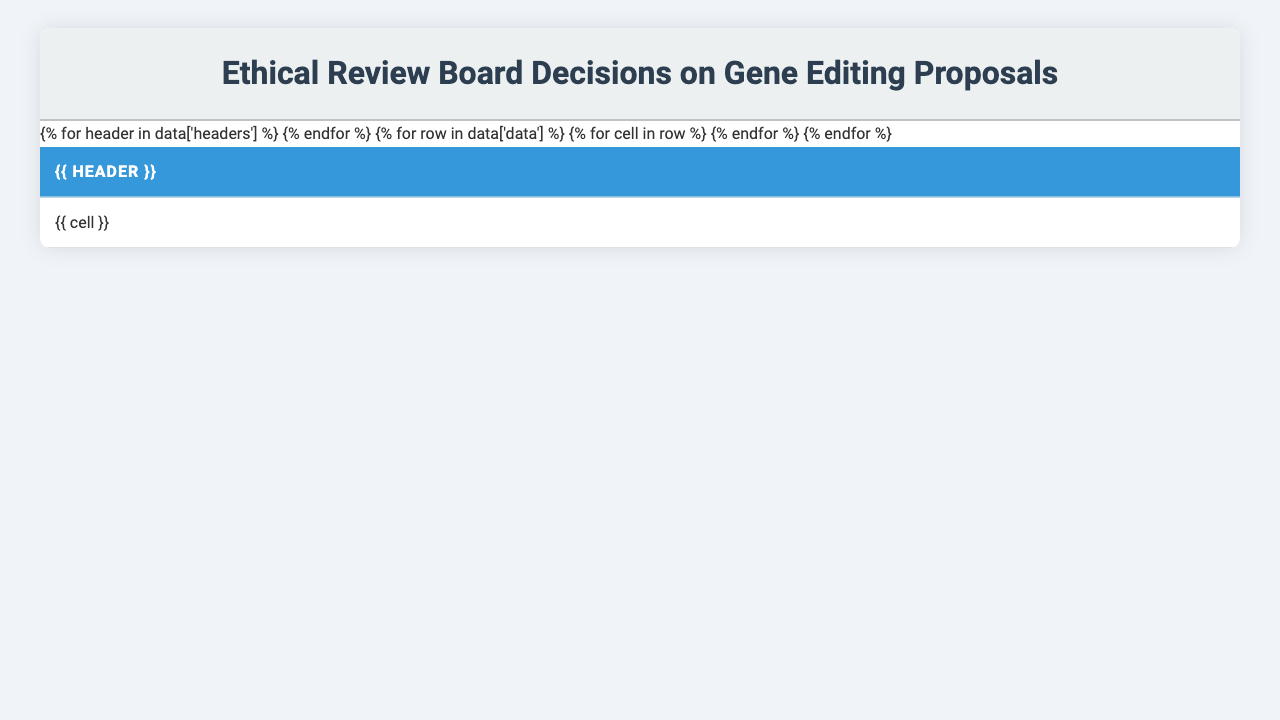What is the most common decision made by the ethical review boards? By examining the "Review Board Decision" column, we see that "Approved" and its variations ("Approved with conditions," "Approved with monitoring," "Approved with safeguards") occur five times, while "Rejected" occurs three times and "Pending" occurs twice. Thus, "Approved" is the most common decision.
Answer: Approved How many proposals were rejected? Upon reviewing the table, there are three proposals that were marked as "Rejected." They are from Harvard Medical School, Broad Institute, and Beijing Genomics Institute.
Answer: 3 What ethical concern was associated with the proposal from UC Berkeley? The proposal from UC Berkeley was related to "Gene drive for malaria-resistant mosquitoes," and the ethical concern identified is "Ecological impact." This matches the corresponding row in the table.
Answer: Ecological impact Which institution had a "Pending further review" decision and in what year? UC Berkeley had a decision of "Pending further review" for the proposal regarding "Gene drive for malaria-resistant mosquitoes," which is listed for the year 2021.
Answer: UC Berkeley, 2021 How many total proposals involved off-target effects as an ethical concern? There are two proposals listed that involve off-target effects—one from Stanford University and another from Max Planck Institute. Thus, the total count is two.
Answer: 2 Which year saw the highest number of rejections? By evaluating the "Year" column alongside the "Review Board Decision," we can see that 2020 has two rejections (Harvard Medical School and Beijing Genomics Institute), which is the highest count for any single year.
Answer: 2020 Was the proposal for germline editing for hereditary deafness approved? The proposal from Harvard Medical School concerning germline editing for hereditary deafness was "Rejected" according to the information in the table.
Answer: No What percentage of total proposals were approved? There are ten proposals in total, and six were approved in some form. To find the percentage, we calculate (6/10)*100 = 60%.
Answer: 60% List the proposals that involved issues of informed consent. The proposal from Karolinska Institute regarding "Prime editing for cystic fibrosis" was associated with "Informed consent issues." This is the only one listed in the table that mentions this concern.
Answer: Prime editing for cystic fibrosis What is the ethical concern tied to the gene editing proposal from Johns Hopkins University? The proposal from Johns Hopkins University concerning somatic cell editing for muscular dystrophy is associated with the ethical concern "Long-term effects unknown," as indicated in the table.
Answer: Long-term effects unknown Compare the number of proposals that were approved with conditions to those that were simply rejected. The table shows that one proposal was "Approved with conditions," while three were "Rejected." Therefore, the comparison reveals significantly more rejections than approvals with conditions.
Answer: More rejections 